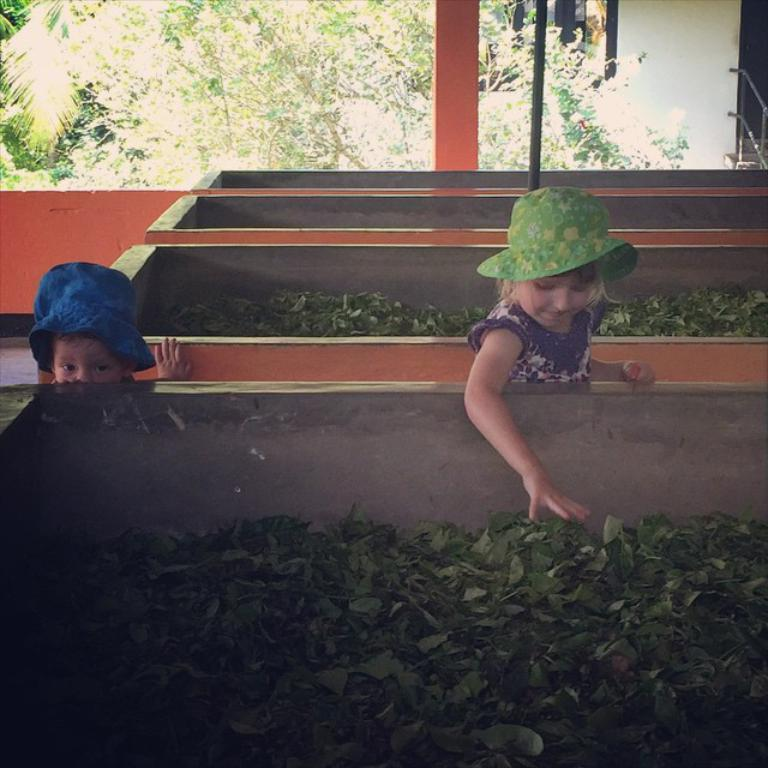Who is present in the image? There are kids in the image. What are the kids doing in the image? The kids are between tanks containing leaves. What can be seen in the background of the image? There are trees at the top of the image. What is the taste of the disgusting bikes in the image? There are no bikes present in the image, and the term "disgust" is not relevant to the image. 